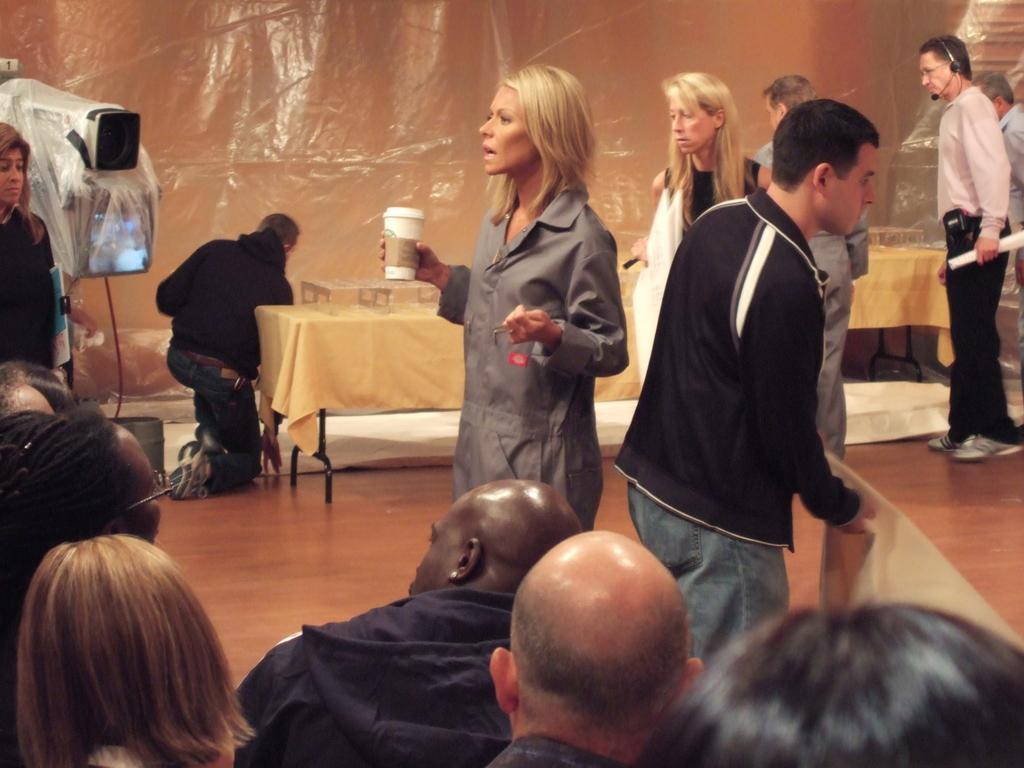Can you describe this image briefly? As we can see in the image, there are group of people sitting, standing and walking here and there and there is a table. On table there is cream color cloth and wall is in brown color. 